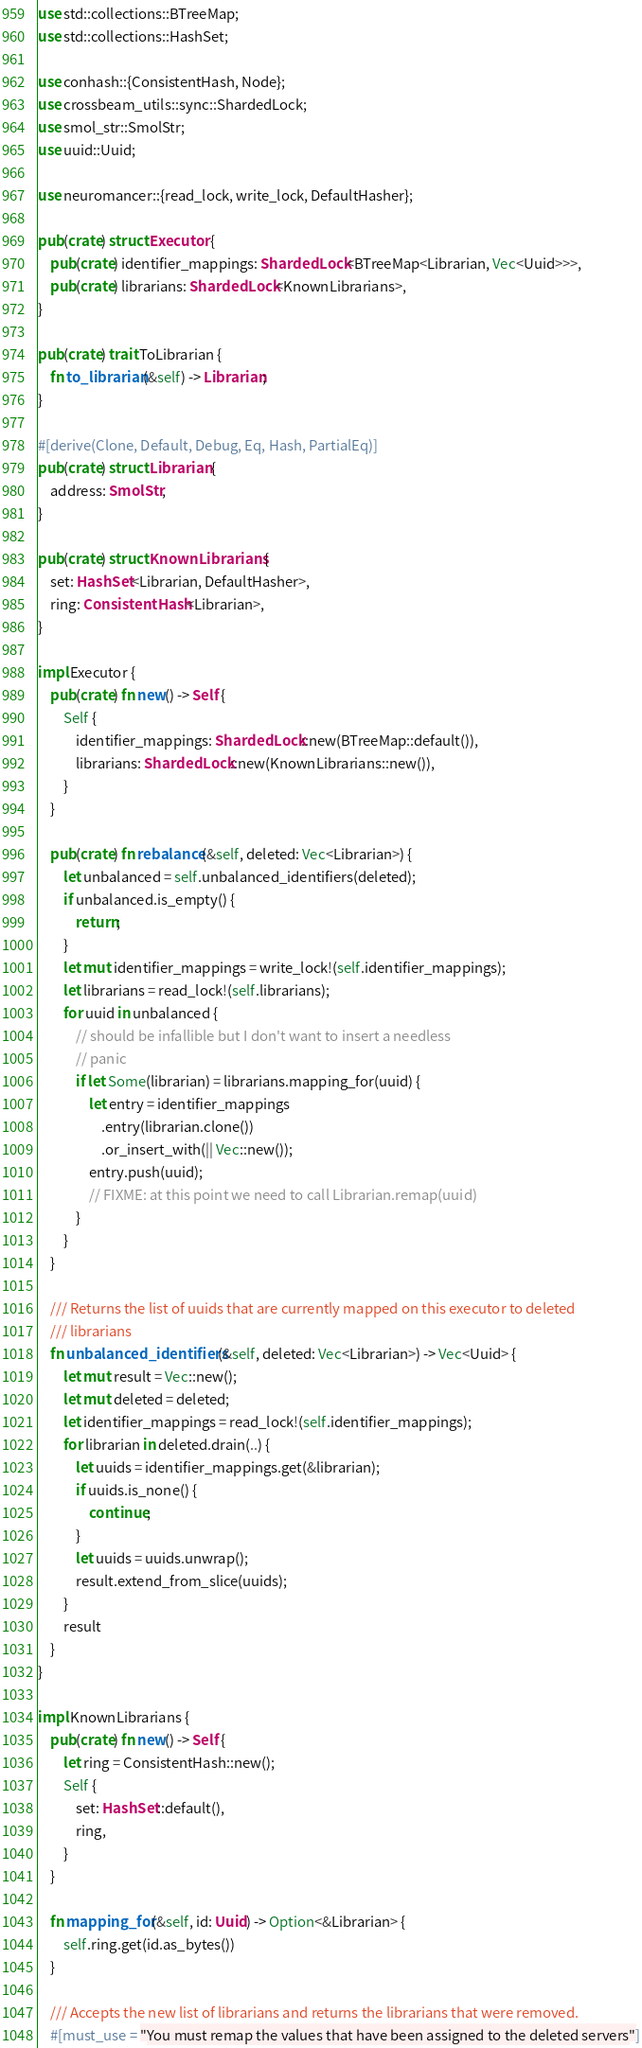Convert code to text. <code><loc_0><loc_0><loc_500><loc_500><_Rust_>use std::collections::BTreeMap;
use std::collections::HashSet;

use conhash::{ConsistentHash, Node};
use crossbeam_utils::sync::ShardedLock;
use smol_str::SmolStr;
use uuid::Uuid;

use neuromancer::{read_lock, write_lock, DefaultHasher};

pub(crate) struct Executor {
    pub(crate) identifier_mappings: ShardedLock<BTreeMap<Librarian, Vec<Uuid>>>,
    pub(crate) librarians: ShardedLock<KnownLibrarians>,
}

pub(crate) trait ToLibrarian {
    fn to_librarian(&self) -> Librarian;
}

#[derive(Clone, Default, Debug, Eq, Hash, PartialEq)]
pub(crate) struct Librarian {
    address: SmolStr,
}

pub(crate) struct KnownLibrarians {
    set: HashSet<Librarian, DefaultHasher>,
    ring: ConsistentHash<Librarian>,
}

impl Executor {
    pub(crate) fn new() -> Self {
        Self {
            identifier_mappings: ShardedLock::new(BTreeMap::default()),
            librarians: ShardedLock::new(KnownLibrarians::new()),
        }
    }

    pub(crate) fn rebalance(&self, deleted: Vec<Librarian>) {
        let unbalanced = self.unbalanced_identifiers(deleted);
        if unbalanced.is_empty() {
            return;
        }
        let mut identifier_mappings = write_lock!(self.identifier_mappings);
        let librarians = read_lock!(self.librarians);
        for uuid in unbalanced {
            // should be infallible but I don't want to insert a needless
            // panic
            if let Some(librarian) = librarians.mapping_for(uuid) {
                let entry = identifier_mappings
                    .entry(librarian.clone())
                    .or_insert_with(|| Vec::new());
                entry.push(uuid);
                // FIXME: at this point we need to call Librarian.remap(uuid)
            }
        }
    }

    /// Returns the list of uuids that are currently mapped on this executor to deleted
    /// librarians
    fn unbalanced_identifiers(&self, deleted: Vec<Librarian>) -> Vec<Uuid> {
        let mut result = Vec::new();
        let mut deleted = deleted;
        let identifier_mappings = read_lock!(self.identifier_mappings);
        for librarian in deleted.drain(..) {
            let uuids = identifier_mappings.get(&librarian);
            if uuids.is_none() {
                continue;
            }
            let uuids = uuids.unwrap();
            result.extend_from_slice(uuids);
        }
        result
    }
}

impl KnownLibrarians {
    pub(crate) fn new() -> Self {
        let ring = ConsistentHash::new();
        Self {
            set: HashSet::default(),
            ring,
        }
    }

    fn mapping_for(&self, id: Uuid) -> Option<&Librarian> {
        self.ring.get(id.as_bytes())
    }

    /// Accepts the new list of librarians and returns the librarians that were removed.
    #[must_use = "You must remap the values that have been assigned to the deleted servers"]</code> 